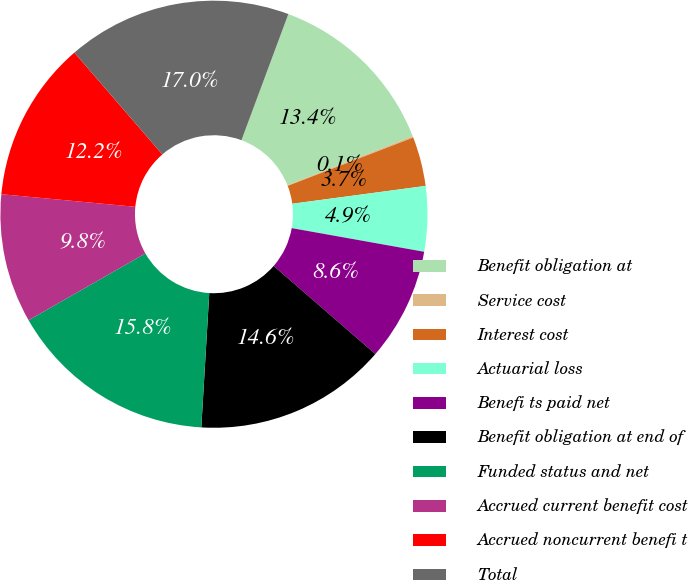Convert chart to OTSL. <chart><loc_0><loc_0><loc_500><loc_500><pie_chart><fcel>Benefit obligation at<fcel>Service cost<fcel>Interest cost<fcel>Actuarial loss<fcel>Benefi ts paid net<fcel>Benefit obligation at end of<fcel>Funded status and net<fcel>Accrued current benefit cost<fcel>Accrued noncurrent benefi t<fcel>Total<nl><fcel>13.38%<fcel>0.11%<fcel>3.73%<fcel>4.93%<fcel>8.55%<fcel>14.58%<fcel>15.79%<fcel>9.76%<fcel>12.17%<fcel>17.0%<nl></chart> 